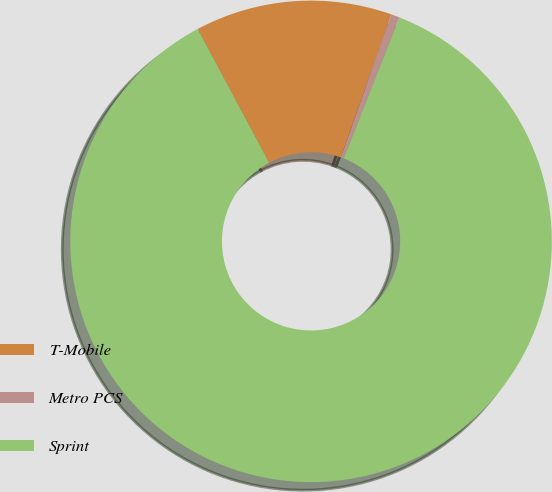<chart> <loc_0><loc_0><loc_500><loc_500><pie_chart><fcel>T-Mobile<fcel>Metro PCS<fcel>Sprint<nl><fcel>13.22%<fcel>0.57%<fcel>86.21%<nl></chart> 